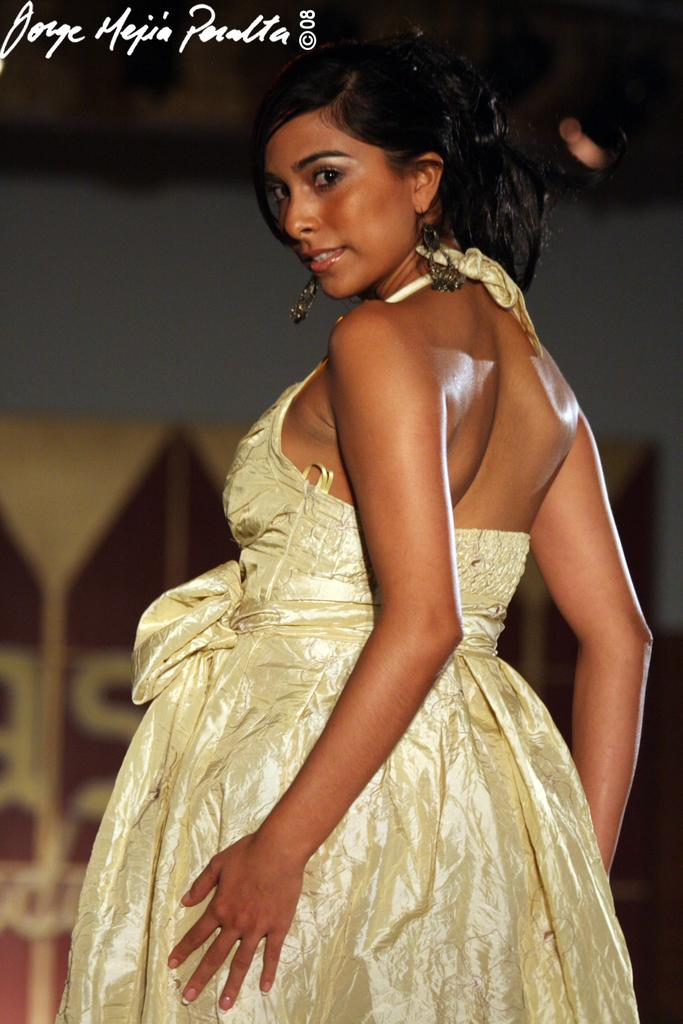Who is the main subject in the image? There is a girl in the center of the image. What can be seen in the background of the image? There is a poster in the background of the image. What type of ant can be seen crawling on the girl's shoulder in the image? There are no ants present in the image; the girl is the main subject in the center of the image. 